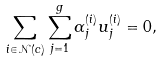Convert formula to latex. <formula><loc_0><loc_0><loc_500><loc_500>\sum _ { i \in \mathcal { N } ( c ) } \sum _ { j = 1 } ^ { g } \alpha _ { j } ^ { ( i ) } u _ { j } ^ { ( i ) } = 0 ,</formula> 